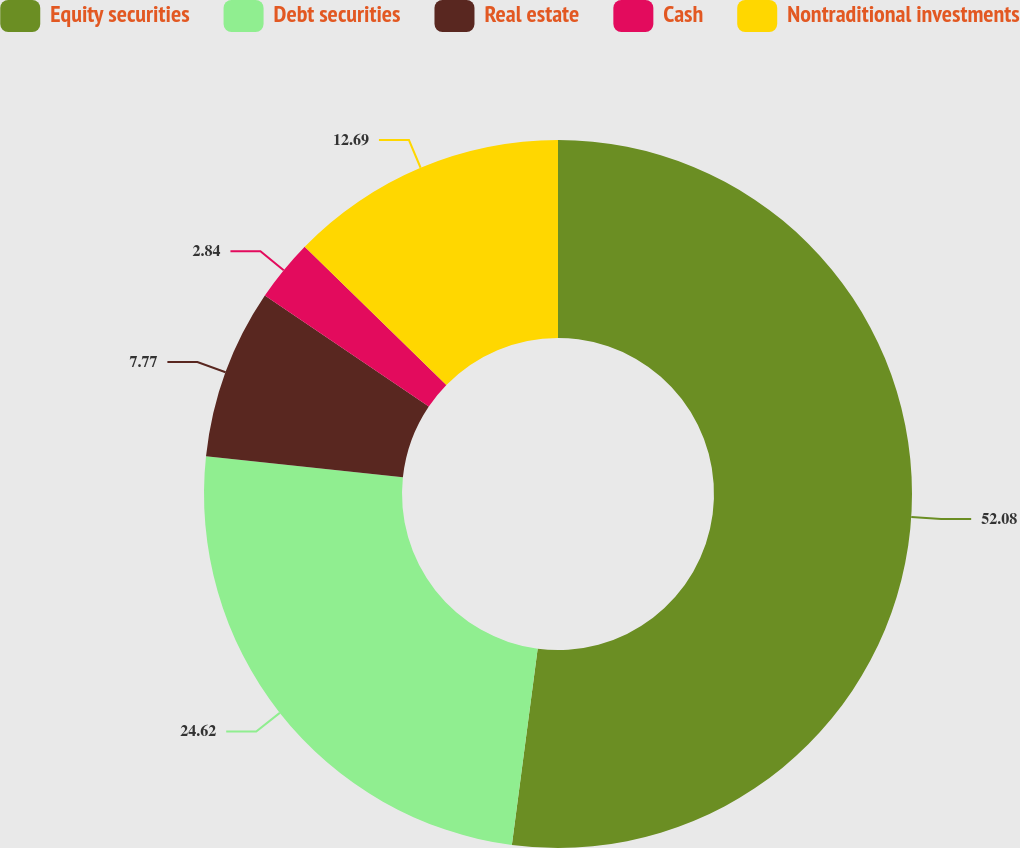Convert chart. <chart><loc_0><loc_0><loc_500><loc_500><pie_chart><fcel>Equity securities<fcel>Debt securities<fcel>Real estate<fcel>Cash<fcel>Nontraditional investments<nl><fcel>52.08%<fcel>24.62%<fcel>7.77%<fcel>2.84%<fcel>12.69%<nl></chart> 